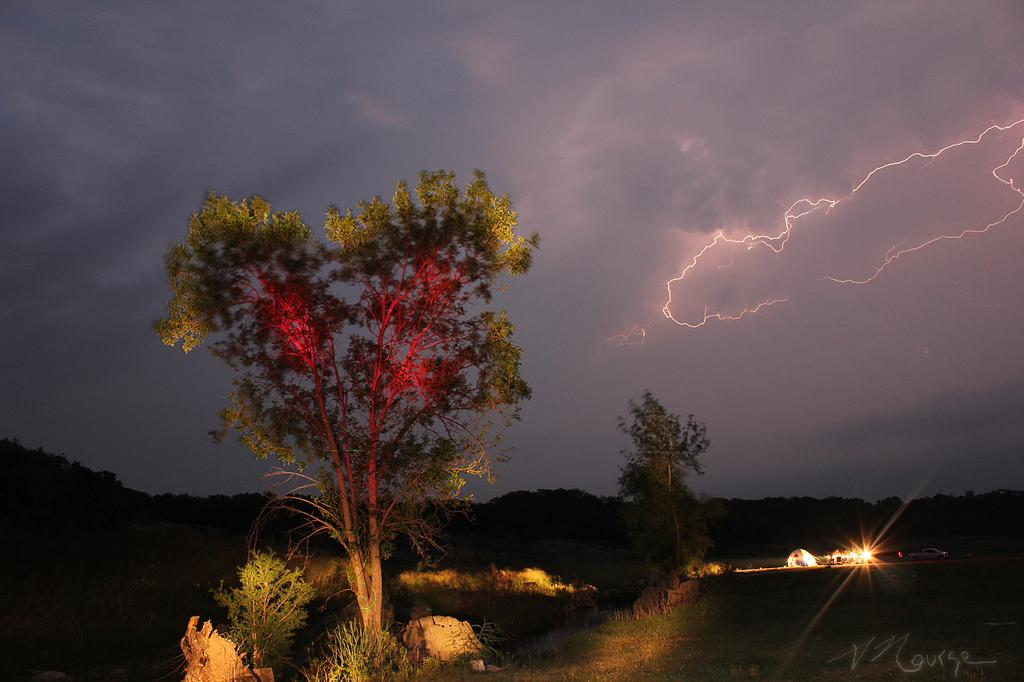What type of shelter is visible in the image? There is a tent in the image. What else can be seen on the ground in the image? There are vehicles on a path in the image. What type of natural elements are present in the image? There are trees and plants in the image. What is happening in the sky in the image? There is lightning in the sky, and the sky is cloudy. What design is featured on the wish-granting stone in the image? There is no wish-granting stone present in the image. What is the cause of the lightning in the image? The cause of the lightning in the image cannot be determined from the image alone. 